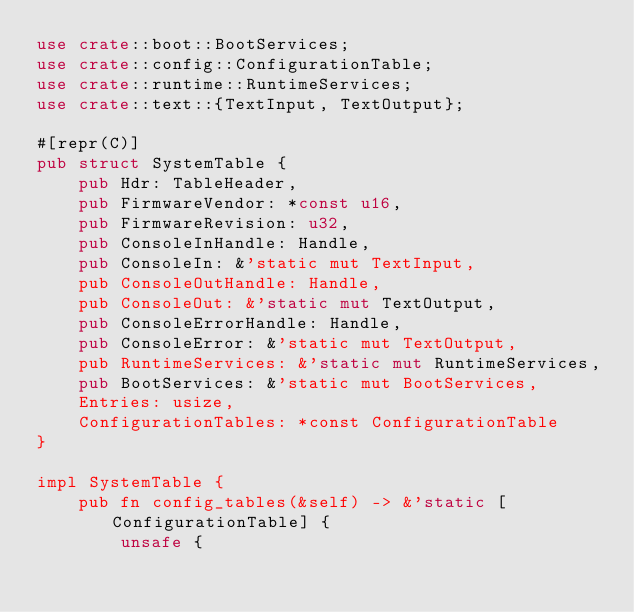Convert code to text. <code><loc_0><loc_0><loc_500><loc_500><_Rust_>use crate::boot::BootServices;
use crate::config::ConfigurationTable;
use crate::runtime::RuntimeServices;
use crate::text::{TextInput, TextOutput};

#[repr(C)]
pub struct SystemTable {
    pub Hdr: TableHeader,
    pub FirmwareVendor: *const u16,
    pub FirmwareRevision: u32,
    pub ConsoleInHandle: Handle,
    pub ConsoleIn: &'static mut TextInput,
    pub ConsoleOutHandle: Handle,
    pub ConsoleOut: &'static mut TextOutput,
    pub ConsoleErrorHandle: Handle,
    pub ConsoleError: &'static mut TextOutput,
    pub RuntimeServices: &'static mut RuntimeServices,
    pub BootServices: &'static mut BootServices,
    Entries: usize,
    ConfigurationTables: *const ConfigurationTable
}

impl SystemTable {
    pub fn config_tables(&self) -> &'static [ConfigurationTable] {
        unsafe {</code> 